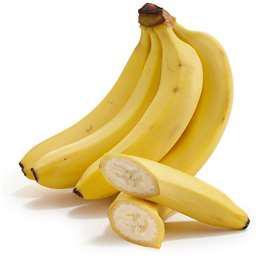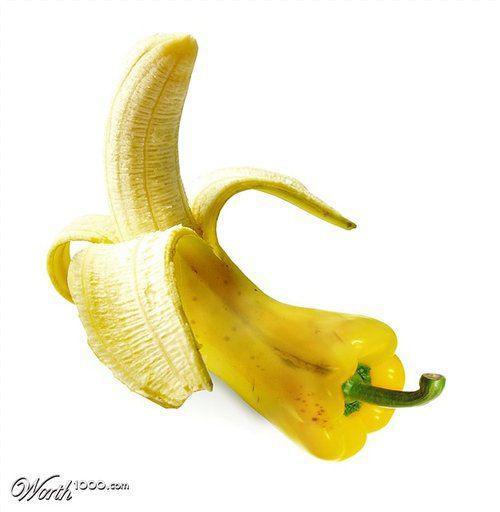The first image is the image on the left, the second image is the image on the right. Given the left and right images, does the statement "One of the images features a vegetable turning in to a banana." hold true? Answer yes or no. Yes. The first image is the image on the left, the second image is the image on the right. Considering the images on both sides, is "There are real bananas in one of the images." valid? Answer yes or no. Yes. 